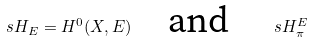<formula> <loc_0><loc_0><loc_500><loc_500>\ s H _ { E } = H ^ { 0 } ( X , E ) \quad \text {and} \quad \ s H _ { \pi } ^ { E }</formula> 